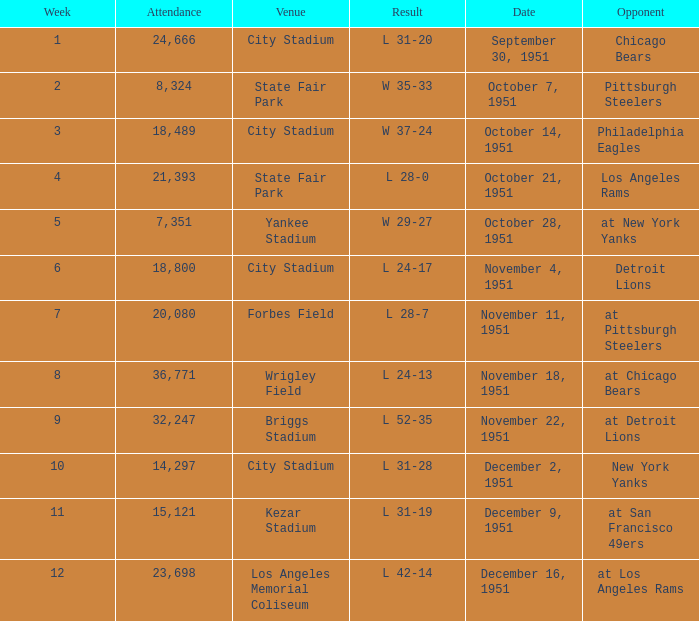Help me parse the entirety of this table. {'header': ['Week', 'Attendance', 'Venue', 'Result', 'Date', 'Opponent'], 'rows': [['1', '24,666', 'City Stadium', 'L 31-20', 'September 30, 1951', 'Chicago Bears'], ['2', '8,324', 'State Fair Park', 'W 35-33', 'October 7, 1951', 'Pittsburgh Steelers'], ['3', '18,489', 'City Stadium', 'W 37-24', 'October 14, 1951', 'Philadelphia Eagles'], ['4', '21,393', 'State Fair Park', 'L 28-0', 'October 21, 1951', 'Los Angeles Rams'], ['5', '7,351', 'Yankee Stadium', 'W 29-27', 'October 28, 1951', 'at New York Yanks'], ['6', '18,800', 'City Stadium', 'L 24-17', 'November 4, 1951', 'Detroit Lions'], ['7', '20,080', 'Forbes Field', 'L 28-7', 'November 11, 1951', 'at Pittsburgh Steelers'], ['8', '36,771', 'Wrigley Field', 'L 24-13', 'November 18, 1951', 'at Chicago Bears'], ['9', '32,247', 'Briggs Stadium', 'L 52-35', 'November 22, 1951', 'at Detroit Lions'], ['10', '14,297', 'City Stadium', 'L 31-28', 'December 2, 1951', 'New York Yanks'], ['11', '15,121', 'Kezar Stadium', 'L 31-19', 'December 9, 1951', 'at San Francisco 49ers'], ['12', '23,698', 'Los Angeles Memorial Coliseum', 'L 42-14', 'December 16, 1951', 'at Los Angeles Rams']]} Which date's week was more than 4 with the venue being City Stadium and where the attendance was more than 14,297? November 4, 1951. 